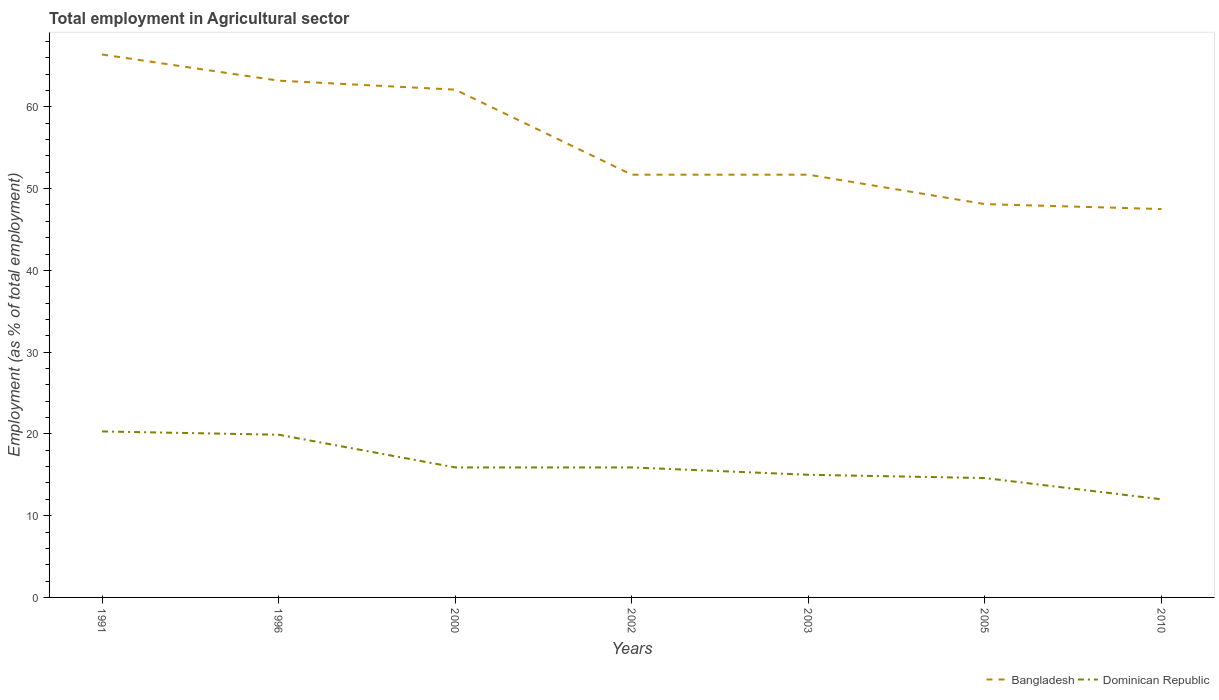Does the line corresponding to Dominican Republic intersect with the line corresponding to Bangladesh?
Make the answer very short. No. Across all years, what is the maximum employment in agricultural sector in Bangladesh?
Your answer should be compact. 47.5. In which year was the employment in agricultural sector in Bangladesh maximum?
Provide a succinct answer. 2010. What is the total employment in agricultural sector in Bangladesh in the graph?
Keep it short and to the point. 11.5. What is the difference between the highest and the second highest employment in agricultural sector in Dominican Republic?
Offer a terse response. 8.3. What is the difference between the highest and the lowest employment in agricultural sector in Dominican Republic?
Your answer should be very brief. 2. Is the employment in agricultural sector in Bangladesh strictly greater than the employment in agricultural sector in Dominican Republic over the years?
Provide a succinct answer. No. How many lines are there?
Offer a terse response. 2. How many years are there in the graph?
Provide a short and direct response. 7. What is the difference between two consecutive major ticks on the Y-axis?
Ensure brevity in your answer.  10. Does the graph contain any zero values?
Offer a very short reply. No. Where does the legend appear in the graph?
Provide a short and direct response. Bottom right. How are the legend labels stacked?
Keep it short and to the point. Horizontal. What is the title of the graph?
Your answer should be very brief. Total employment in Agricultural sector. What is the label or title of the X-axis?
Your answer should be compact. Years. What is the label or title of the Y-axis?
Keep it short and to the point. Employment (as % of total employment). What is the Employment (as % of total employment) of Bangladesh in 1991?
Provide a short and direct response. 66.4. What is the Employment (as % of total employment) of Dominican Republic in 1991?
Provide a short and direct response. 20.3. What is the Employment (as % of total employment) in Bangladesh in 1996?
Make the answer very short. 63.2. What is the Employment (as % of total employment) of Dominican Republic in 1996?
Keep it short and to the point. 19.9. What is the Employment (as % of total employment) in Bangladesh in 2000?
Your response must be concise. 62.1. What is the Employment (as % of total employment) of Dominican Republic in 2000?
Your answer should be very brief. 15.9. What is the Employment (as % of total employment) in Bangladesh in 2002?
Your answer should be very brief. 51.7. What is the Employment (as % of total employment) of Dominican Republic in 2002?
Your answer should be very brief. 15.9. What is the Employment (as % of total employment) of Bangladesh in 2003?
Ensure brevity in your answer.  51.7. What is the Employment (as % of total employment) in Dominican Republic in 2003?
Your answer should be very brief. 15. What is the Employment (as % of total employment) in Bangladesh in 2005?
Give a very brief answer. 48.1. What is the Employment (as % of total employment) of Dominican Republic in 2005?
Offer a very short reply. 14.6. What is the Employment (as % of total employment) in Bangladesh in 2010?
Provide a succinct answer. 47.5. What is the Employment (as % of total employment) of Dominican Republic in 2010?
Give a very brief answer. 12. Across all years, what is the maximum Employment (as % of total employment) in Bangladesh?
Ensure brevity in your answer.  66.4. Across all years, what is the maximum Employment (as % of total employment) of Dominican Republic?
Give a very brief answer. 20.3. Across all years, what is the minimum Employment (as % of total employment) in Bangladesh?
Your answer should be compact. 47.5. What is the total Employment (as % of total employment) in Bangladesh in the graph?
Your answer should be very brief. 390.7. What is the total Employment (as % of total employment) of Dominican Republic in the graph?
Offer a very short reply. 113.6. What is the difference between the Employment (as % of total employment) in Bangladesh in 1991 and that in 2002?
Your response must be concise. 14.7. What is the difference between the Employment (as % of total employment) in Dominican Republic in 1991 and that in 2002?
Offer a terse response. 4.4. What is the difference between the Employment (as % of total employment) in Bangladesh in 1991 and that in 2003?
Your response must be concise. 14.7. What is the difference between the Employment (as % of total employment) in Dominican Republic in 1991 and that in 2003?
Provide a short and direct response. 5.3. What is the difference between the Employment (as % of total employment) of Dominican Republic in 1991 and that in 2005?
Offer a terse response. 5.7. What is the difference between the Employment (as % of total employment) in Bangladesh in 1991 and that in 2010?
Provide a succinct answer. 18.9. What is the difference between the Employment (as % of total employment) in Dominican Republic in 1991 and that in 2010?
Your answer should be very brief. 8.3. What is the difference between the Employment (as % of total employment) in Bangladesh in 1996 and that in 2000?
Your answer should be compact. 1.1. What is the difference between the Employment (as % of total employment) of Dominican Republic in 1996 and that in 2000?
Give a very brief answer. 4. What is the difference between the Employment (as % of total employment) of Bangladesh in 1996 and that in 2005?
Offer a terse response. 15.1. What is the difference between the Employment (as % of total employment) of Dominican Republic in 1996 and that in 2010?
Make the answer very short. 7.9. What is the difference between the Employment (as % of total employment) of Bangladesh in 2000 and that in 2002?
Your answer should be very brief. 10.4. What is the difference between the Employment (as % of total employment) in Bangladesh in 2000 and that in 2003?
Make the answer very short. 10.4. What is the difference between the Employment (as % of total employment) in Dominican Republic in 2000 and that in 2003?
Provide a short and direct response. 0.9. What is the difference between the Employment (as % of total employment) in Bangladesh in 2000 and that in 2005?
Provide a short and direct response. 14. What is the difference between the Employment (as % of total employment) in Bangladesh in 2000 and that in 2010?
Your response must be concise. 14.6. What is the difference between the Employment (as % of total employment) of Bangladesh in 2002 and that in 2010?
Your answer should be compact. 4.2. What is the difference between the Employment (as % of total employment) in Dominican Republic in 2003 and that in 2005?
Keep it short and to the point. 0.4. What is the difference between the Employment (as % of total employment) in Bangladesh in 2003 and that in 2010?
Offer a very short reply. 4.2. What is the difference between the Employment (as % of total employment) of Bangladesh in 2005 and that in 2010?
Your response must be concise. 0.6. What is the difference between the Employment (as % of total employment) in Bangladesh in 1991 and the Employment (as % of total employment) in Dominican Republic in 1996?
Your response must be concise. 46.5. What is the difference between the Employment (as % of total employment) in Bangladesh in 1991 and the Employment (as % of total employment) in Dominican Republic in 2000?
Provide a succinct answer. 50.5. What is the difference between the Employment (as % of total employment) in Bangladesh in 1991 and the Employment (as % of total employment) in Dominican Republic in 2002?
Give a very brief answer. 50.5. What is the difference between the Employment (as % of total employment) in Bangladesh in 1991 and the Employment (as % of total employment) in Dominican Republic in 2003?
Provide a succinct answer. 51.4. What is the difference between the Employment (as % of total employment) in Bangladesh in 1991 and the Employment (as % of total employment) in Dominican Republic in 2005?
Your response must be concise. 51.8. What is the difference between the Employment (as % of total employment) in Bangladesh in 1991 and the Employment (as % of total employment) in Dominican Republic in 2010?
Your response must be concise. 54.4. What is the difference between the Employment (as % of total employment) of Bangladesh in 1996 and the Employment (as % of total employment) of Dominican Republic in 2000?
Provide a succinct answer. 47.3. What is the difference between the Employment (as % of total employment) of Bangladesh in 1996 and the Employment (as % of total employment) of Dominican Republic in 2002?
Offer a very short reply. 47.3. What is the difference between the Employment (as % of total employment) in Bangladesh in 1996 and the Employment (as % of total employment) in Dominican Republic in 2003?
Ensure brevity in your answer.  48.2. What is the difference between the Employment (as % of total employment) in Bangladesh in 1996 and the Employment (as % of total employment) in Dominican Republic in 2005?
Keep it short and to the point. 48.6. What is the difference between the Employment (as % of total employment) of Bangladesh in 1996 and the Employment (as % of total employment) of Dominican Republic in 2010?
Provide a succinct answer. 51.2. What is the difference between the Employment (as % of total employment) in Bangladesh in 2000 and the Employment (as % of total employment) in Dominican Republic in 2002?
Make the answer very short. 46.2. What is the difference between the Employment (as % of total employment) in Bangladesh in 2000 and the Employment (as % of total employment) in Dominican Republic in 2003?
Your answer should be compact. 47.1. What is the difference between the Employment (as % of total employment) of Bangladesh in 2000 and the Employment (as % of total employment) of Dominican Republic in 2005?
Your response must be concise. 47.5. What is the difference between the Employment (as % of total employment) of Bangladesh in 2000 and the Employment (as % of total employment) of Dominican Republic in 2010?
Your answer should be very brief. 50.1. What is the difference between the Employment (as % of total employment) of Bangladesh in 2002 and the Employment (as % of total employment) of Dominican Republic in 2003?
Keep it short and to the point. 36.7. What is the difference between the Employment (as % of total employment) in Bangladesh in 2002 and the Employment (as % of total employment) in Dominican Republic in 2005?
Provide a succinct answer. 37.1. What is the difference between the Employment (as % of total employment) in Bangladesh in 2002 and the Employment (as % of total employment) in Dominican Republic in 2010?
Your answer should be compact. 39.7. What is the difference between the Employment (as % of total employment) of Bangladesh in 2003 and the Employment (as % of total employment) of Dominican Republic in 2005?
Make the answer very short. 37.1. What is the difference between the Employment (as % of total employment) of Bangladesh in 2003 and the Employment (as % of total employment) of Dominican Republic in 2010?
Ensure brevity in your answer.  39.7. What is the difference between the Employment (as % of total employment) in Bangladesh in 2005 and the Employment (as % of total employment) in Dominican Republic in 2010?
Keep it short and to the point. 36.1. What is the average Employment (as % of total employment) in Bangladesh per year?
Give a very brief answer. 55.81. What is the average Employment (as % of total employment) in Dominican Republic per year?
Offer a very short reply. 16.23. In the year 1991, what is the difference between the Employment (as % of total employment) in Bangladesh and Employment (as % of total employment) in Dominican Republic?
Your answer should be very brief. 46.1. In the year 1996, what is the difference between the Employment (as % of total employment) in Bangladesh and Employment (as % of total employment) in Dominican Republic?
Offer a terse response. 43.3. In the year 2000, what is the difference between the Employment (as % of total employment) in Bangladesh and Employment (as % of total employment) in Dominican Republic?
Make the answer very short. 46.2. In the year 2002, what is the difference between the Employment (as % of total employment) of Bangladesh and Employment (as % of total employment) of Dominican Republic?
Your response must be concise. 35.8. In the year 2003, what is the difference between the Employment (as % of total employment) of Bangladesh and Employment (as % of total employment) of Dominican Republic?
Keep it short and to the point. 36.7. In the year 2005, what is the difference between the Employment (as % of total employment) in Bangladesh and Employment (as % of total employment) in Dominican Republic?
Keep it short and to the point. 33.5. In the year 2010, what is the difference between the Employment (as % of total employment) in Bangladesh and Employment (as % of total employment) in Dominican Republic?
Provide a short and direct response. 35.5. What is the ratio of the Employment (as % of total employment) of Bangladesh in 1991 to that in 1996?
Keep it short and to the point. 1.05. What is the ratio of the Employment (as % of total employment) of Dominican Republic in 1991 to that in 1996?
Offer a very short reply. 1.02. What is the ratio of the Employment (as % of total employment) of Bangladesh in 1991 to that in 2000?
Provide a short and direct response. 1.07. What is the ratio of the Employment (as % of total employment) in Dominican Republic in 1991 to that in 2000?
Your response must be concise. 1.28. What is the ratio of the Employment (as % of total employment) of Bangladesh in 1991 to that in 2002?
Keep it short and to the point. 1.28. What is the ratio of the Employment (as % of total employment) in Dominican Republic in 1991 to that in 2002?
Your answer should be very brief. 1.28. What is the ratio of the Employment (as % of total employment) of Bangladesh in 1991 to that in 2003?
Make the answer very short. 1.28. What is the ratio of the Employment (as % of total employment) in Dominican Republic in 1991 to that in 2003?
Your response must be concise. 1.35. What is the ratio of the Employment (as % of total employment) of Bangladesh in 1991 to that in 2005?
Your answer should be compact. 1.38. What is the ratio of the Employment (as % of total employment) in Dominican Republic in 1991 to that in 2005?
Your response must be concise. 1.39. What is the ratio of the Employment (as % of total employment) in Bangladesh in 1991 to that in 2010?
Your answer should be very brief. 1.4. What is the ratio of the Employment (as % of total employment) of Dominican Republic in 1991 to that in 2010?
Ensure brevity in your answer.  1.69. What is the ratio of the Employment (as % of total employment) in Bangladesh in 1996 to that in 2000?
Keep it short and to the point. 1.02. What is the ratio of the Employment (as % of total employment) in Dominican Republic in 1996 to that in 2000?
Your answer should be compact. 1.25. What is the ratio of the Employment (as % of total employment) of Bangladesh in 1996 to that in 2002?
Your response must be concise. 1.22. What is the ratio of the Employment (as % of total employment) of Dominican Republic in 1996 to that in 2002?
Offer a very short reply. 1.25. What is the ratio of the Employment (as % of total employment) in Bangladesh in 1996 to that in 2003?
Provide a succinct answer. 1.22. What is the ratio of the Employment (as % of total employment) in Dominican Republic in 1996 to that in 2003?
Your answer should be very brief. 1.33. What is the ratio of the Employment (as % of total employment) of Bangladesh in 1996 to that in 2005?
Make the answer very short. 1.31. What is the ratio of the Employment (as % of total employment) in Dominican Republic in 1996 to that in 2005?
Keep it short and to the point. 1.36. What is the ratio of the Employment (as % of total employment) of Bangladesh in 1996 to that in 2010?
Provide a short and direct response. 1.33. What is the ratio of the Employment (as % of total employment) of Dominican Republic in 1996 to that in 2010?
Your response must be concise. 1.66. What is the ratio of the Employment (as % of total employment) of Bangladesh in 2000 to that in 2002?
Provide a succinct answer. 1.2. What is the ratio of the Employment (as % of total employment) of Dominican Republic in 2000 to that in 2002?
Keep it short and to the point. 1. What is the ratio of the Employment (as % of total employment) of Bangladesh in 2000 to that in 2003?
Keep it short and to the point. 1.2. What is the ratio of the Employment (as % of total employment) of Dominican Republic in 2000 to that in 2003?
Provide a succinct answer. 1.06. What is the ratio of the Employment (as % of total employment) of Bangladesh in 2000 to that in 2005?
Your response must be concise. 1.29. What is the ratio of the Employment (as % of total employment) in Dominican Republic in 2000 to that in 2005?
Provide a succinct answer. 1.09. What is the ratio of the Employment (as % of total employment) in Bangladesh in 2000 to that in 2010?
Ensure brevity in your answer.  1.31. What is the ratio of the Employment (as % of total employment) of Dominican Republic in 2000 to that in 2010?
Your answer should be compact. 1.32. What is the ratio of the Employment (as % of total employment) of Bangladesh in 2002 to that in 2003?
Offer a very short reply. 1. What is the ratio of the Employment (as % of total employment) of Dominican Republic in 2002 to that in 2003?
Your response must be concise. 1.06. What is the ratio of the Employment (as % of total employment) of Bangladesh in 2002 to that in 2005?
Give a very brief answer. 1.07. What is the ratio of the Employment (as % of total employment) of Dominican Republic in 2002 to that in 2005?
Offer a terse response. 1.09. What is the ratio of the Employment (as % of total employment) in Bangladesh in 2002 to that in 2010?
Provide a short and direct response. 1.09. What is the ratio of the Employment (as % of total employment) in Dominican Republic in 2002 to that in 2010?
Provide a short and direct response. 1.32. What is the ratio of the Employment (as % of total employment) of Bangladesh in 2003 to that in 2005?
Ensure brevity in your answer.  1.07. What is the ratio of the Employment (as % of total employment) of Dominican Republic in 2003 to that in 2005?
Provide a succinct answer. 1.03. What is the ratio of the Employment (as % of total employment) in Bangladesh in 2003 to that in 2010?
Ensure brevity in your answer.  1.09. What is the ratio of the Employment (as % of total employment) in Dominican Republic in 2003 to that in 2010?
Give a very brief answer. 1.25. What is the ratio of the Employment (as % of total employment) in Bangladesh in 2005 to that in 2010?
Give a very brief answer. 1.01. What is the ratio of the Employment (as % of total employment) of Dominican Republic in 2005 to that in 2010?
Give a very brief answer. 1.22. What is the difference between the highest and the second highest Employment (as % of total employment) of Dominican Republic?
Provide a succinct answer. 0.4. What is the difference between the highest and the lowest Employment (as % of total employment) in Bangladesh?
Give a very brief answer. 18.9. 